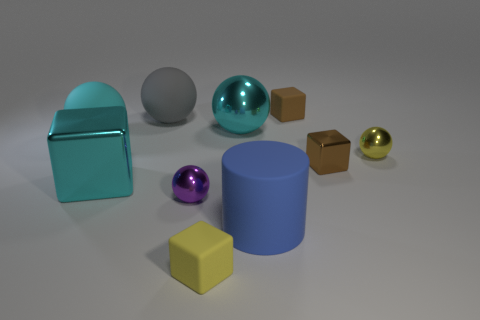What is the size of the cyan ball that is left of the small rubber object in front of the cyan cube?
Provide a succinct answer. Large. What material is the big ball that is in front of the cyan shiny ball?
Your answer should be compact. Rubber. What number of things are balls behind the large cyan rubber object or rubber objects in front of the large gray matte sphere?
Your answer should be compact. 5. There is another brown thing that is the same shape as the brown rubber thing; what material is it?
Provide a succinct answer. Metal. There is a cube behind the tiny brown metal block; does it have the same color as the metallic cube that is to the right of the brown rubber object?
Offer a terse response. Yes. Is there a blue matte cylinder of the same size as the brown rubber cube?
Ensure brevity in your answer.  No. There is a small block that is both behind the tiny purple sphere and in front of the large gray matte object; what is its material?
Ensure brevity in your answer.  Metal. What number of metallic objects are either purple objects or big purple cubes?
Make the answer very short. 1. What shape is the tiny thing that is the same material as the yellow cube?
Provide a succinct answer. Cube. How many large cyan shiny things are behind the brown metal block and on the left side of the yellow matte object?
Provide a short and direct response. 0. 